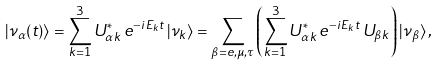<formula> <loc_0><loc_0><loc_500><loc_500>| \nu _ { \alpha } ( t ) \rangle = \sum _ { k = 1 } ^ { 3 } U _ { \alpha k } ^ { * } \, e ^ { - i E _ { k } t } \, | \nu _ { k } \rangle = \sum _ { \beta = e , \mu , \tau } \left ( \sum _ { k = 1 } ^ { 3 } U _ { \alpha k } ^ { * } \, e ^ { - i E _ { k } t } \, U _ { \beta k } \right ) | \nu _ { \beta } \rangle \, ,</formula> 